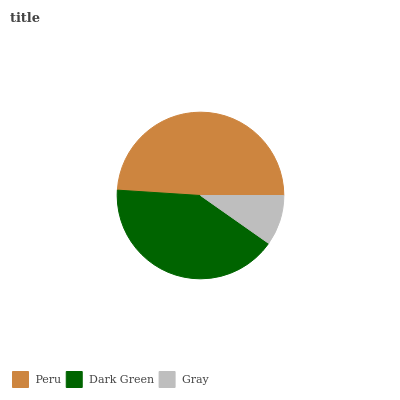Is Gray the minimum?
Answer yes or no. Yes. Is Peru the maximum?
Answer yes or no. Yes. Is Dark Green the minimum?
Answer yes or no. No. Is Dark Green the maximum?
Answer yes or no. No. Is Peru greater than Dark Green?
Answer yes or no. Yes. Is Dark Green less than Peru?
Answer yes or no. Yes. Is Dark Green greater than Peru?
Answer yes or no. No. Is Peru less than Dark Green?
Answer yes or no. No. Is Dark Green the high median?
Answer yes or no. Yes. Is Dark Green the low median?
Answer yes or no. Yes. Is Gray the high median?
Answer yes or no. No. Is Gray the low median?
Answer yes or no. No. 